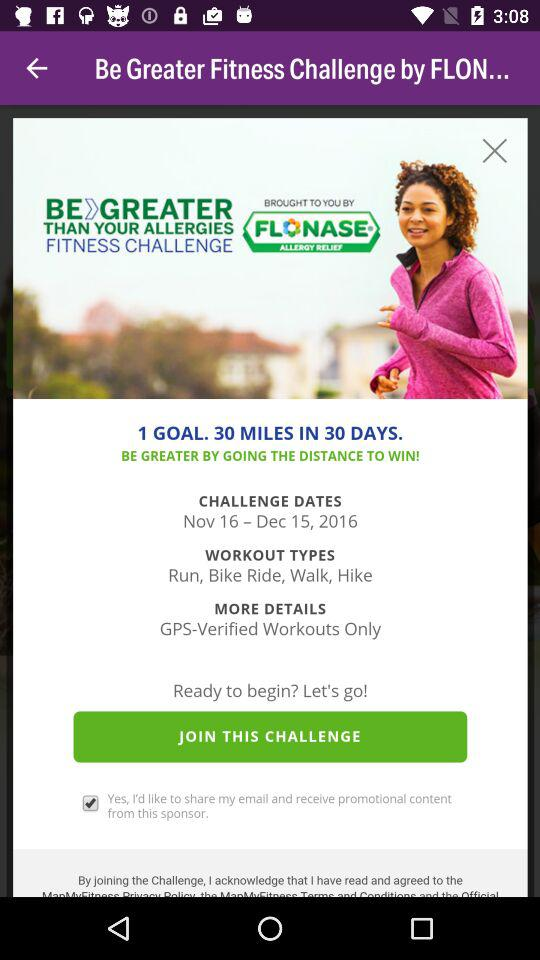Which workout types are given? The given workout types are running, biking, walking, and hiking. 